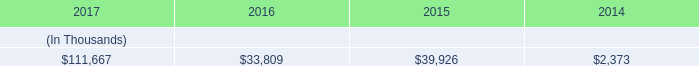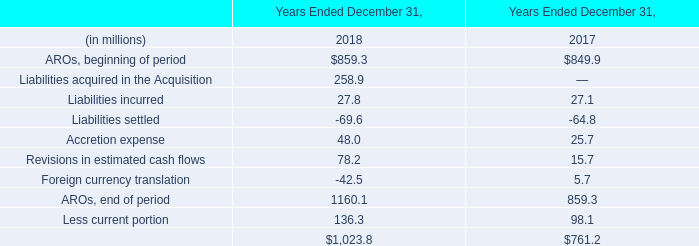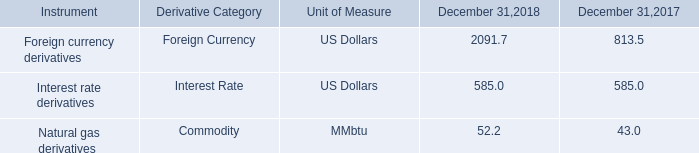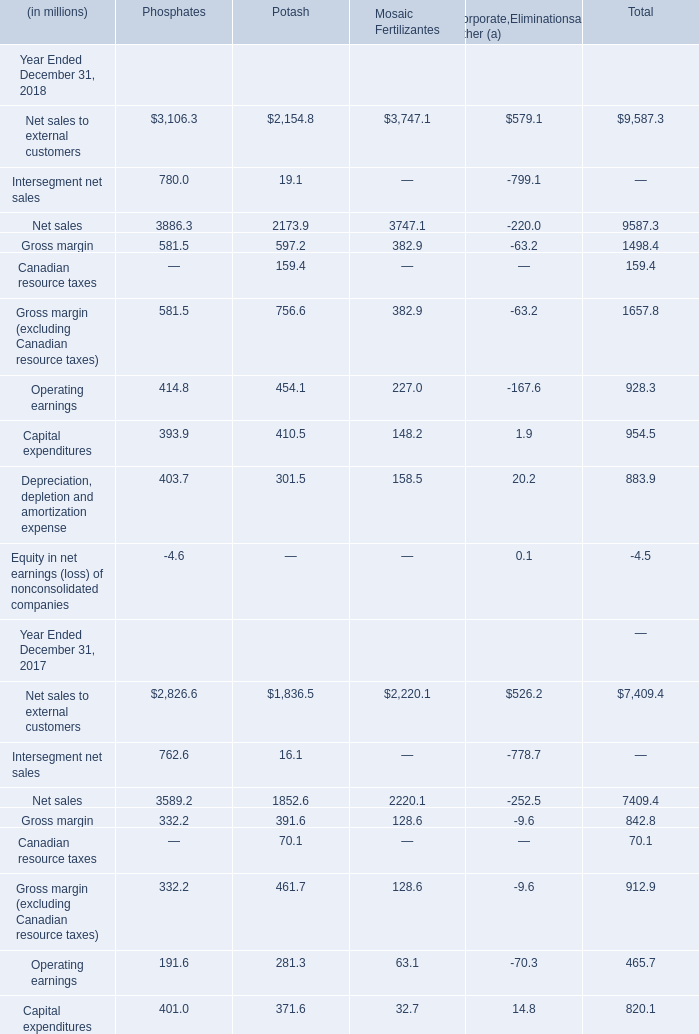What's the average of the Net sales to external customers for Phosphates in the years where Liabilities incurred is greater than 0? (in million) 
Computations: ((3106.3 + 2826.6) / 2)
Answer: 2966.45. 